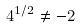<formula> <loc_0><loc_0><loc_500><loc_500>4 ^ { 1 / 2 } \ne - 2</formula> 